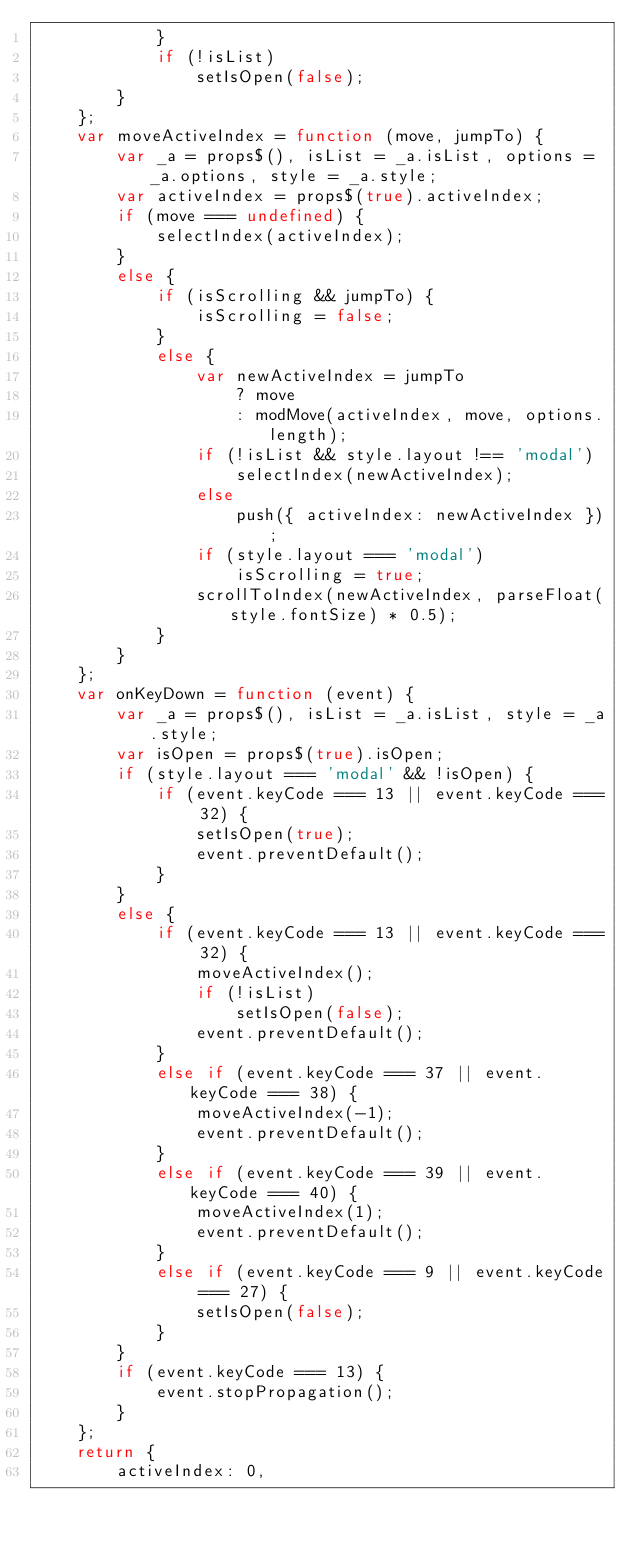Convert code to text. <code><loc_0><loc_0><loc_500><loc_500><_JavaScript_>            }
            if (!isList)
                setIsOpen(false);
        }
    };
    var moveActiveIndex = function (move, jumpTo) {
        var _a = props$(), isList = _a.isList, options = _a.options, style = _a.style;
        var activeIndex = props$(true).activeIndex;
        if (move === undefined) {
            selectIndex(activeIndex);
        }
        else {
            if (isScrolling && jumpTo) {
                isScrolling = false;
            }
            else {
                var newActiveIndex = jumpTo
                    ? move
                    : modMove(activeIndex, move, options.length);
                if (!isList && style.layout !== 'modal')
                    selectIndex(newActiveIndex);
                else
                    push({ activeIndex: newActiveIndex });
                if (style.layout === 'modal')
                    isScrolling = true;
                scrollToIndex(newActiveIndex, parseFloat(style.fontSize) * 0.5);
            }
        }
    };
    var onKeyDown = function (event) {
        var _a = props$(), isList = _a.isList, style = _a.style;
        var isOpen = props$(true).isOpen;
        if (style.layout === 'modal' && !isOpen) {
            if (event.keyCode === 13 || event.keyCode === 32) {
                setIsOpen(true);
                event.preventDefault();
            }
        }
        else {
            if (event.keyCode === 13 || event.keyCode === 32) {
                moveActiveIndex();
                if (!isList)
                    setIsOpen(false);
                event.preventDefault();
            }
            else if (event.keyCode === 37 || event.keyCode === 38) {
                moveActiveIndex(-1);
                event.preventDefault();
            }
            else if (event.keyCode === 39 || event.keyCode === 40) {
                moveActiveIndex(1);
                event.preventDefault();
            }
            else if (event.keyCode === 9 || event.keyCode === 27) {
                setIsOpen(false);
            }
        }
        if (event.keyCode === 13) {
            event.stopPropagation();
        }
    };
    return {
        activeIndex: 0,</code> 